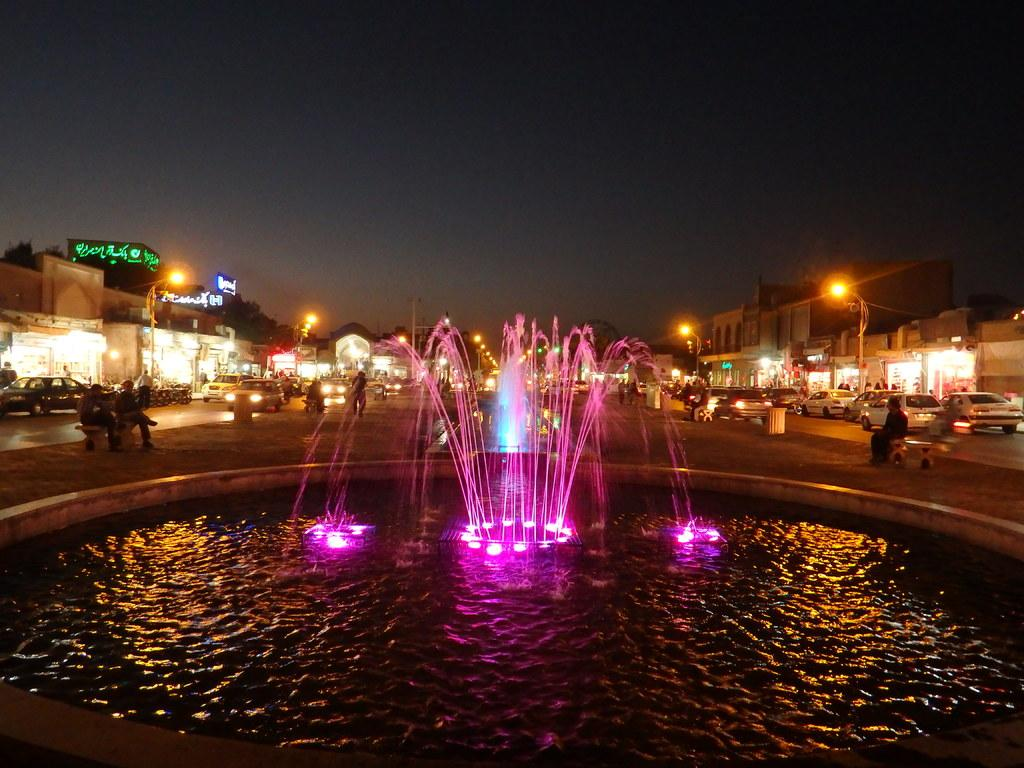What is the main feature in the image? There is a fountain in the image. What can be seen in the image besides the fountain? There are lights, people, vehicles, stalls, light poles, and the sky visible in the image. Can you describe the people in the image? Some people are standing, while others are sitting. What type of structures are present in the background of the image? There are stalls in the background of the image. What type of paste is being used to fix the plough in the image? There is no plough or paste present in the image; it features a fountain, lights, people, vehicles, stalls, light poles, and the sky. 